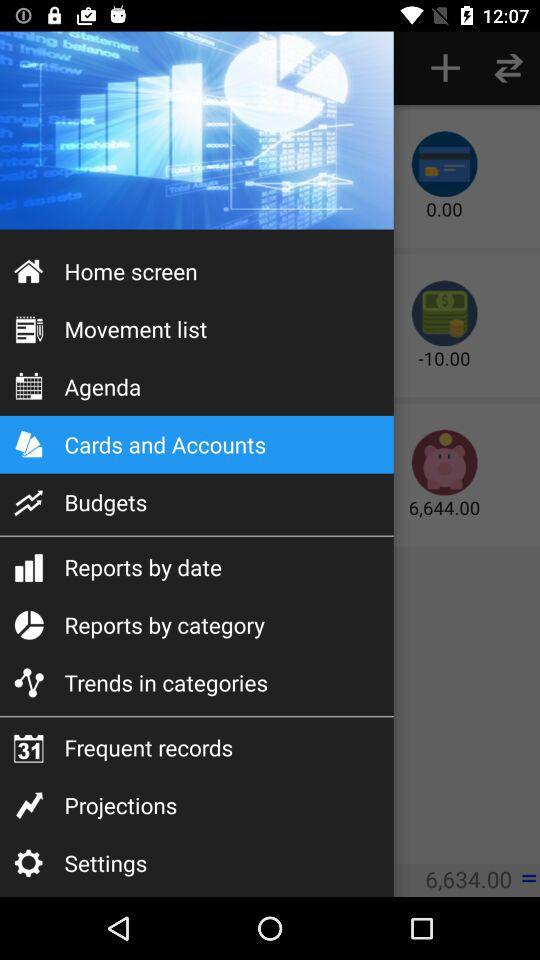What is the total amount of money in my accounts?
Answer the question using a single word or phrase. 6,634.00 